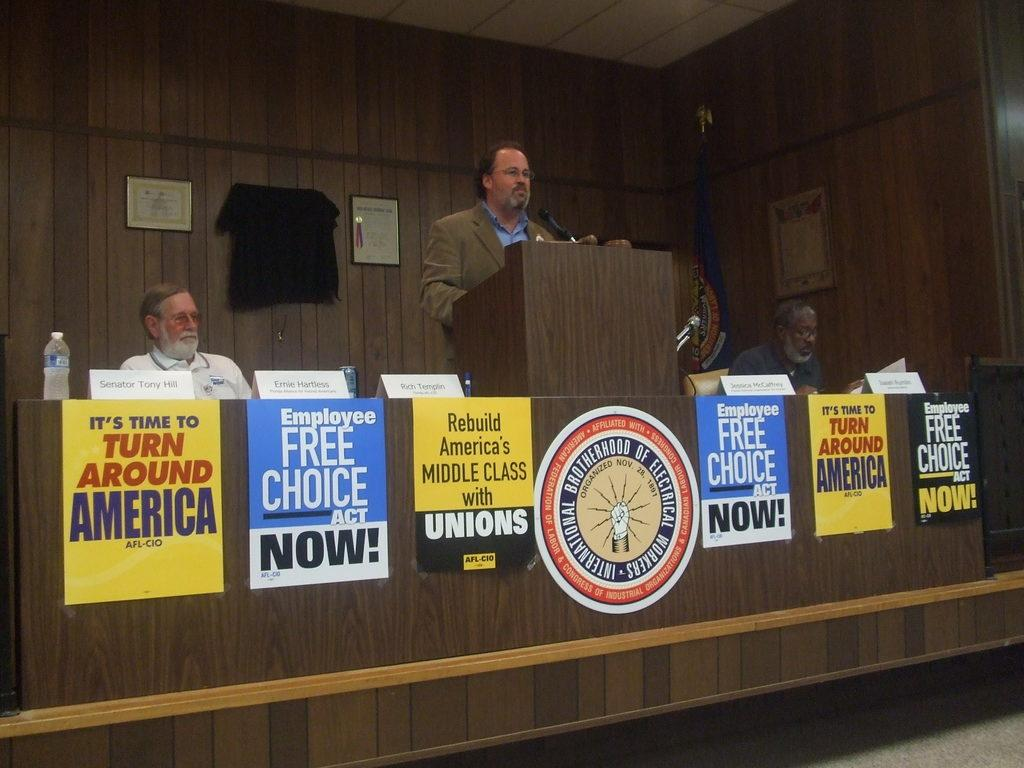<image>
Create a compact narrative representing the image presented. A bearded man speaks at a podium plastered with "Free Choice Now" and "Turn Around America" posters. 